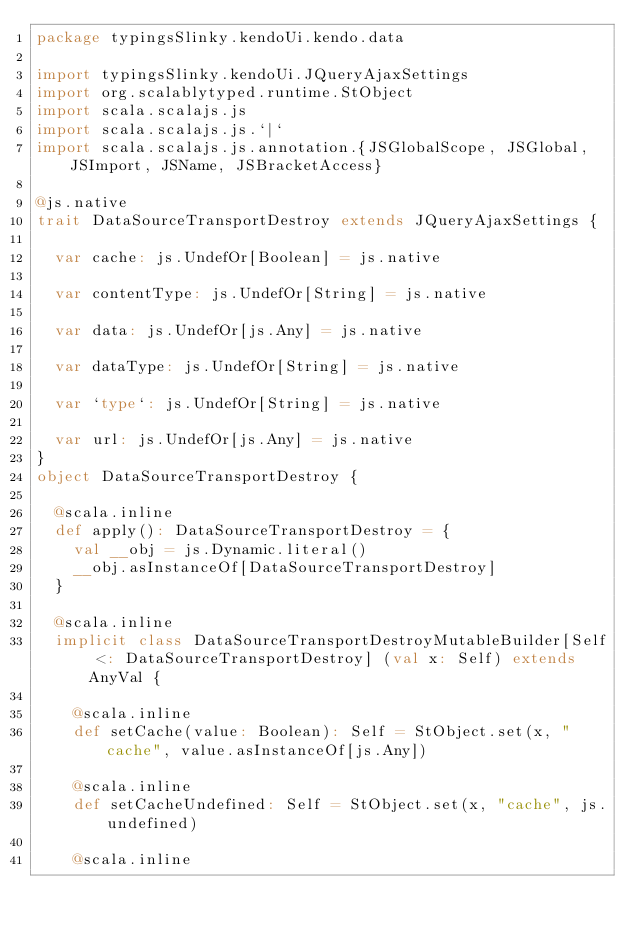Convert code to text. <code><loc_0><loc_0><loc_500><loc_500><_Scala_>package typingsSlinky.kendoUi.kendo.data

import typingsSlinky.kendoUi.JQueryAjaxSettings
import org.scalablytyped.runtime.StObject
import scala.scalajs.js
import scala.scalajs.js.`|`
import scala.scalajs.js.annotation.{JSGlobalScope, JSGlobal, JSImport, JSName, JSBracketAccess}

@js.native
trait DataSourceTransportDestroy extends JQueryAjaxSettings {
  
  var cache: js.UndefOr[Boolean] = js.native
  
  var contentType: js.UndefOr[String] = js.native
  
  var data: js.UndefOr[js.Any] = js.native
  
  var dataType: js.UndefOr[String] = js.native
  
  var `type`: js.UndefOr[String] = js.native
  
  var url: js.UndefOr[js.Any] = js.native
}
object DataSourceTransportDestroy {
  
  @scala.inline
  def apply(): DataSourceTransportDestroy = {
    val __obj = js.Dynamic.literal()
    __obj.asInstanceOf[DataSourceTransportDestroy]
  }
  
  @scala.inline
  implicit class DataSourceTransportDestroyMutableBuilder[Self <: DataSourceTransportDestroy] (val x: Self) extends AnyVal {
    
    @scala.inline
    def setCache(value: Boolean): Self = StObject.set(x, "cache", value.asInstanceOf[js.Any])
    
    @scala.inline
    def setCacheUndefined: Self = StObject.set(x, "cache", js.undefined)
    
    @scala.inline</code> 